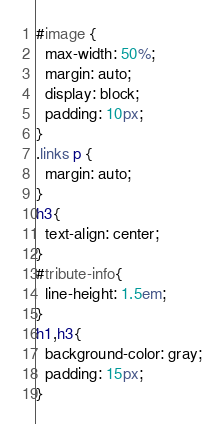Convert code to text. <code><loc_0><loc_0><loc_500><loc_500><_CSS_>#image {
  max-width: 50%;
  margin: auto;
  display: block;
  padding: 10px;
}
.links p {
  margin: auto;
}
h3{
  text-align: center;
}
#tribute-info{
  line-height: 1.5em;
}
h1,h3{
  background-color: gray;
  padding: 15px;
}
</code> 